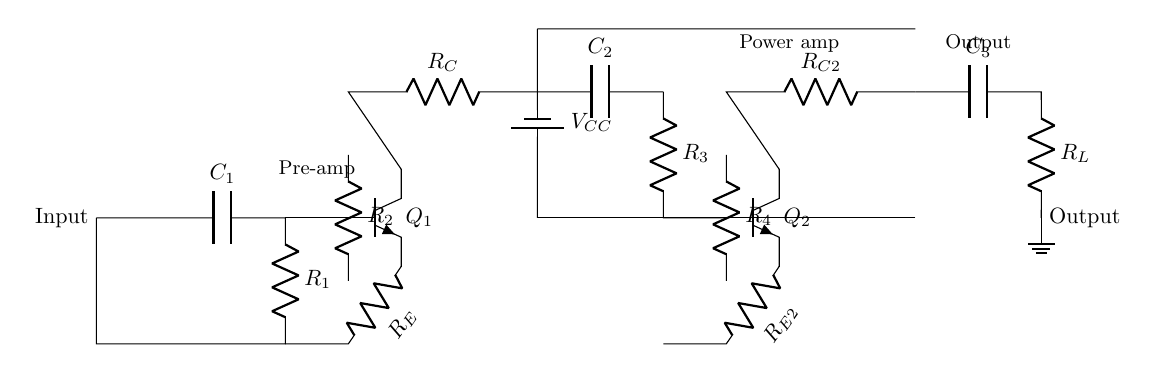What is the first component connected to the input? The first component after the input is a capacitor labeled C1.
Answer: C1 What is the role of Q1 in this circuit? Q1 is an npn transistor that functions as the first amplification stage, receiving the input signal and amplifying it through its collector and emitter pins.
Answer: First amplification What is the total number of resistors in the circuit? By counting the resistors labeled R1, R2, R3, R4, RC, and RE, there are a total of five resistors present.
Answer: Five What is the type of the second transistor used in the circuit? The second transistor Q2, like the first, is also an npn type and serves as the second amplification stage.
Answer: NPN What is the function of capacitor C3? C3 acts as a coupling capacitor, allowing the amplified audio signal to pass to the output stage while blocking any DC component.
Answer: Coupling How does the output connect to the ground? The output resistor labeled RL is directly connected to the ground, which completes the circuit and allows the signal to flow to the output.
Answer: Direct connection What power supply voltage is used in this amplifier? The battery supplying the circuit is labeled VCC, which indicates the positive supply voltage, typically for the transistors' operation, but the exact value is not specified.
Answer: VCC 